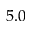<formula> <loc_0><loc_0><loc_500><loc_500>5 . 0</formula> 